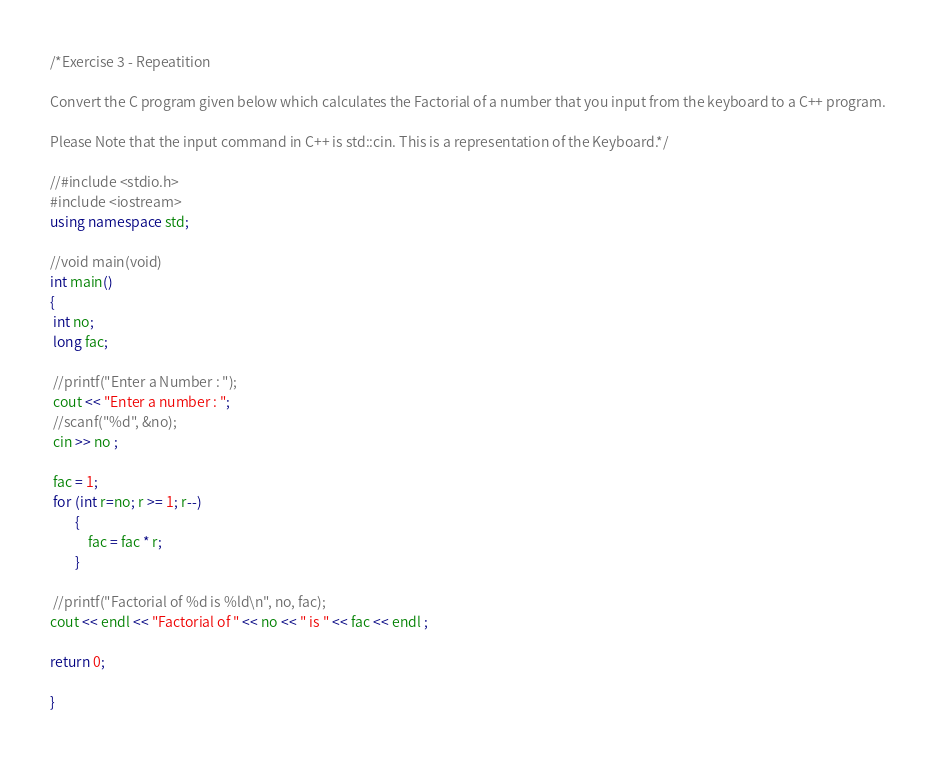<code> <loc_0><loc_0><loc_500><loc_500><_C++_>/*Exercise 3 - Repeatition

Convert the C program given below which calculates the Factorial of a number that you input from the keyboard to a C++ program.

Please Note that the input command in C++ is std::cin. This is a representation of the Keyboard.*/

//#include <stdio.h>
#include <iostream>
using namespace std;

//void main(void)
int main()
{
 int no;
 long fac;
 
 //printf("Enter a Number : ");
 cout << "Enter a number : ";
 //scanf("%d", &no);
 cin >> no ;
 
 fac = 1;
 for (int r=no; r >= 1; r--) 
 		{
 			fac = fac * r;
 		}
 		
 //printf("Factorial of %d is %ld\n", no, fac); 
cout << endl << "Factorial of " << no << " is " << fac << endl ;

return 0;

}</code> 